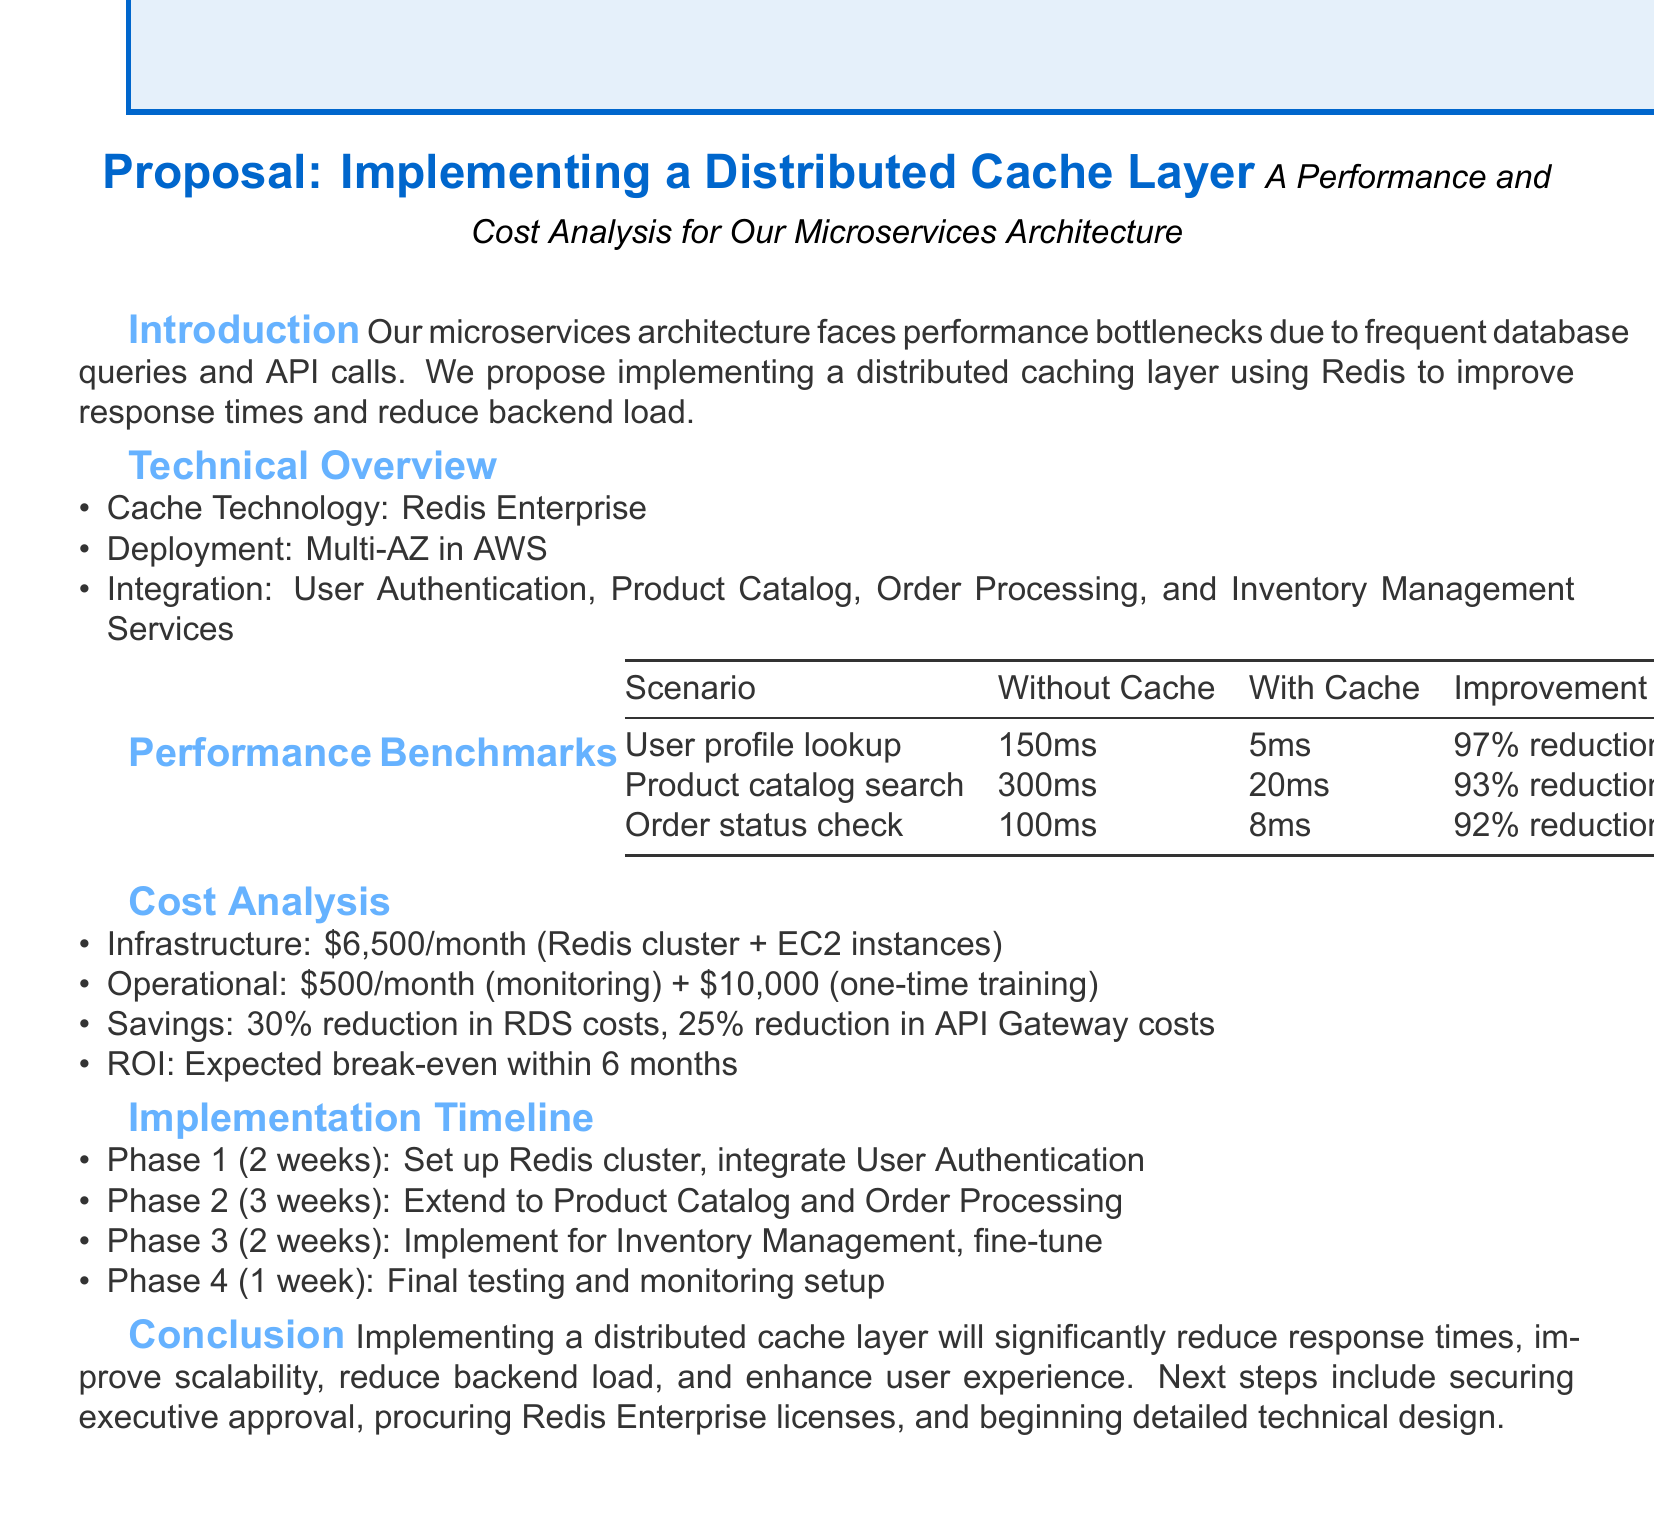What is the proposed solution to the performance issue? The proposed solution to the performance issue is to implement a distributed caching layer using Redis.
Answer: Distributed caching layer using Redis What is the average response time for product catalog search without cache? The average response time for product catalog search without cache is specified in the performance benchmarks section.
Answer: 300 milliseconds What is the estimated reduction in RDS instance costs? The estimated reduction in RDS instance costs is detailed in the cost analysis section.
Answer: 30 percent What is the duration of Phase 1 in the implementation timeline? The duration of Phase 1 is mentioned in the implementation timeline section of the document.
Answer: 2 weeks What cache invalidation strategy is proposed? The proposed cache invalidation strategy is stated in the implementation details.
Answer: Time-based expiration with event-driven updates What are the key benefits of implementing a distributed cache layer? The key benefits are outlined in the conclusion section of the document.
Answer: Significant reduction in response times How many concurrent users were used in the load testing methodology? The number of concurrent users is found in the methodology of the performance benchmarks.
Answer: 10,000 concurrent users What is the one-time cost for Redis certification training? The one-time cost for Redis certification training is specified in the operational costs.
Answer: $10,000 